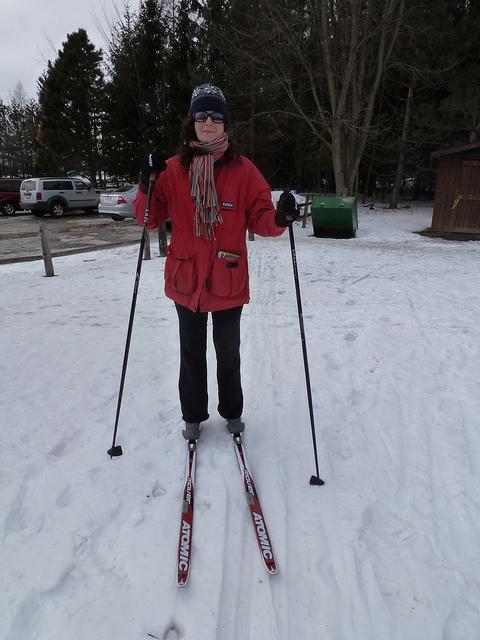Is the person in the photograph working at a bank when the photo is taken?
Quick response, please. No. Is the woman dressed properly for this activity?
Keep it brief. Yes. How much snow is on the ground?
Answer briefly. Lot. How many vehicles are in the background?
Write a very short answer. 2. 